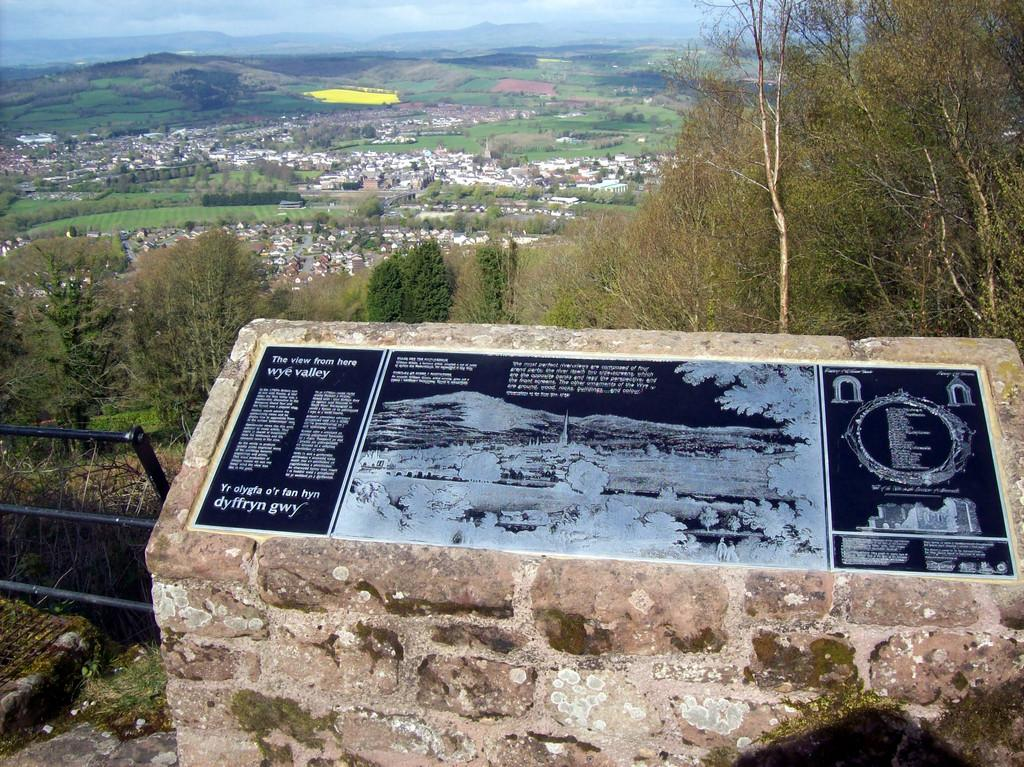What type of natural elements can be seen in the image? There are trees in the image. What type of man-made structures can be seen in the image? There are houses in the image. What type of geographical feature can be seen in the image? There are mountains in the image. What type of barrier can be seen in the image? There is fencing in the image. What is attached to a wall in the image? There is a board attached to a wall in the image. What is written on the board in the image? Something is written on the board in the image. Can you tell me how many squirrels are climbing on the trees in the image? There is no squirrel present in the image; only trees, houses, mountains, fencing, a board, and something written on the board can be seen. What type of alarm is attached to the board in the image? There is no alarm present in the image; only a board with something written on it can be seen. 